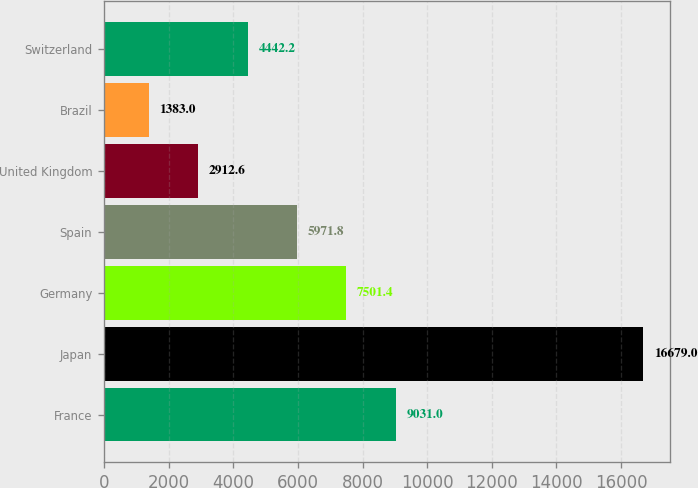Convert chart. <chart><loc_0><loc_0><loc_500><loc_500><bar_chart><fcel>France<fcel>Japan<fcel>Germany<fcel>Spain<fcel>United Kingdom<fcel>Brazil<fcel>Switzerland<nl><fcel>9031<fcel>16679<fcel>7501.4<fcel>5971.8<fcel>2912.6<fcel>1383<fcel>4442.2<nl></chart> 